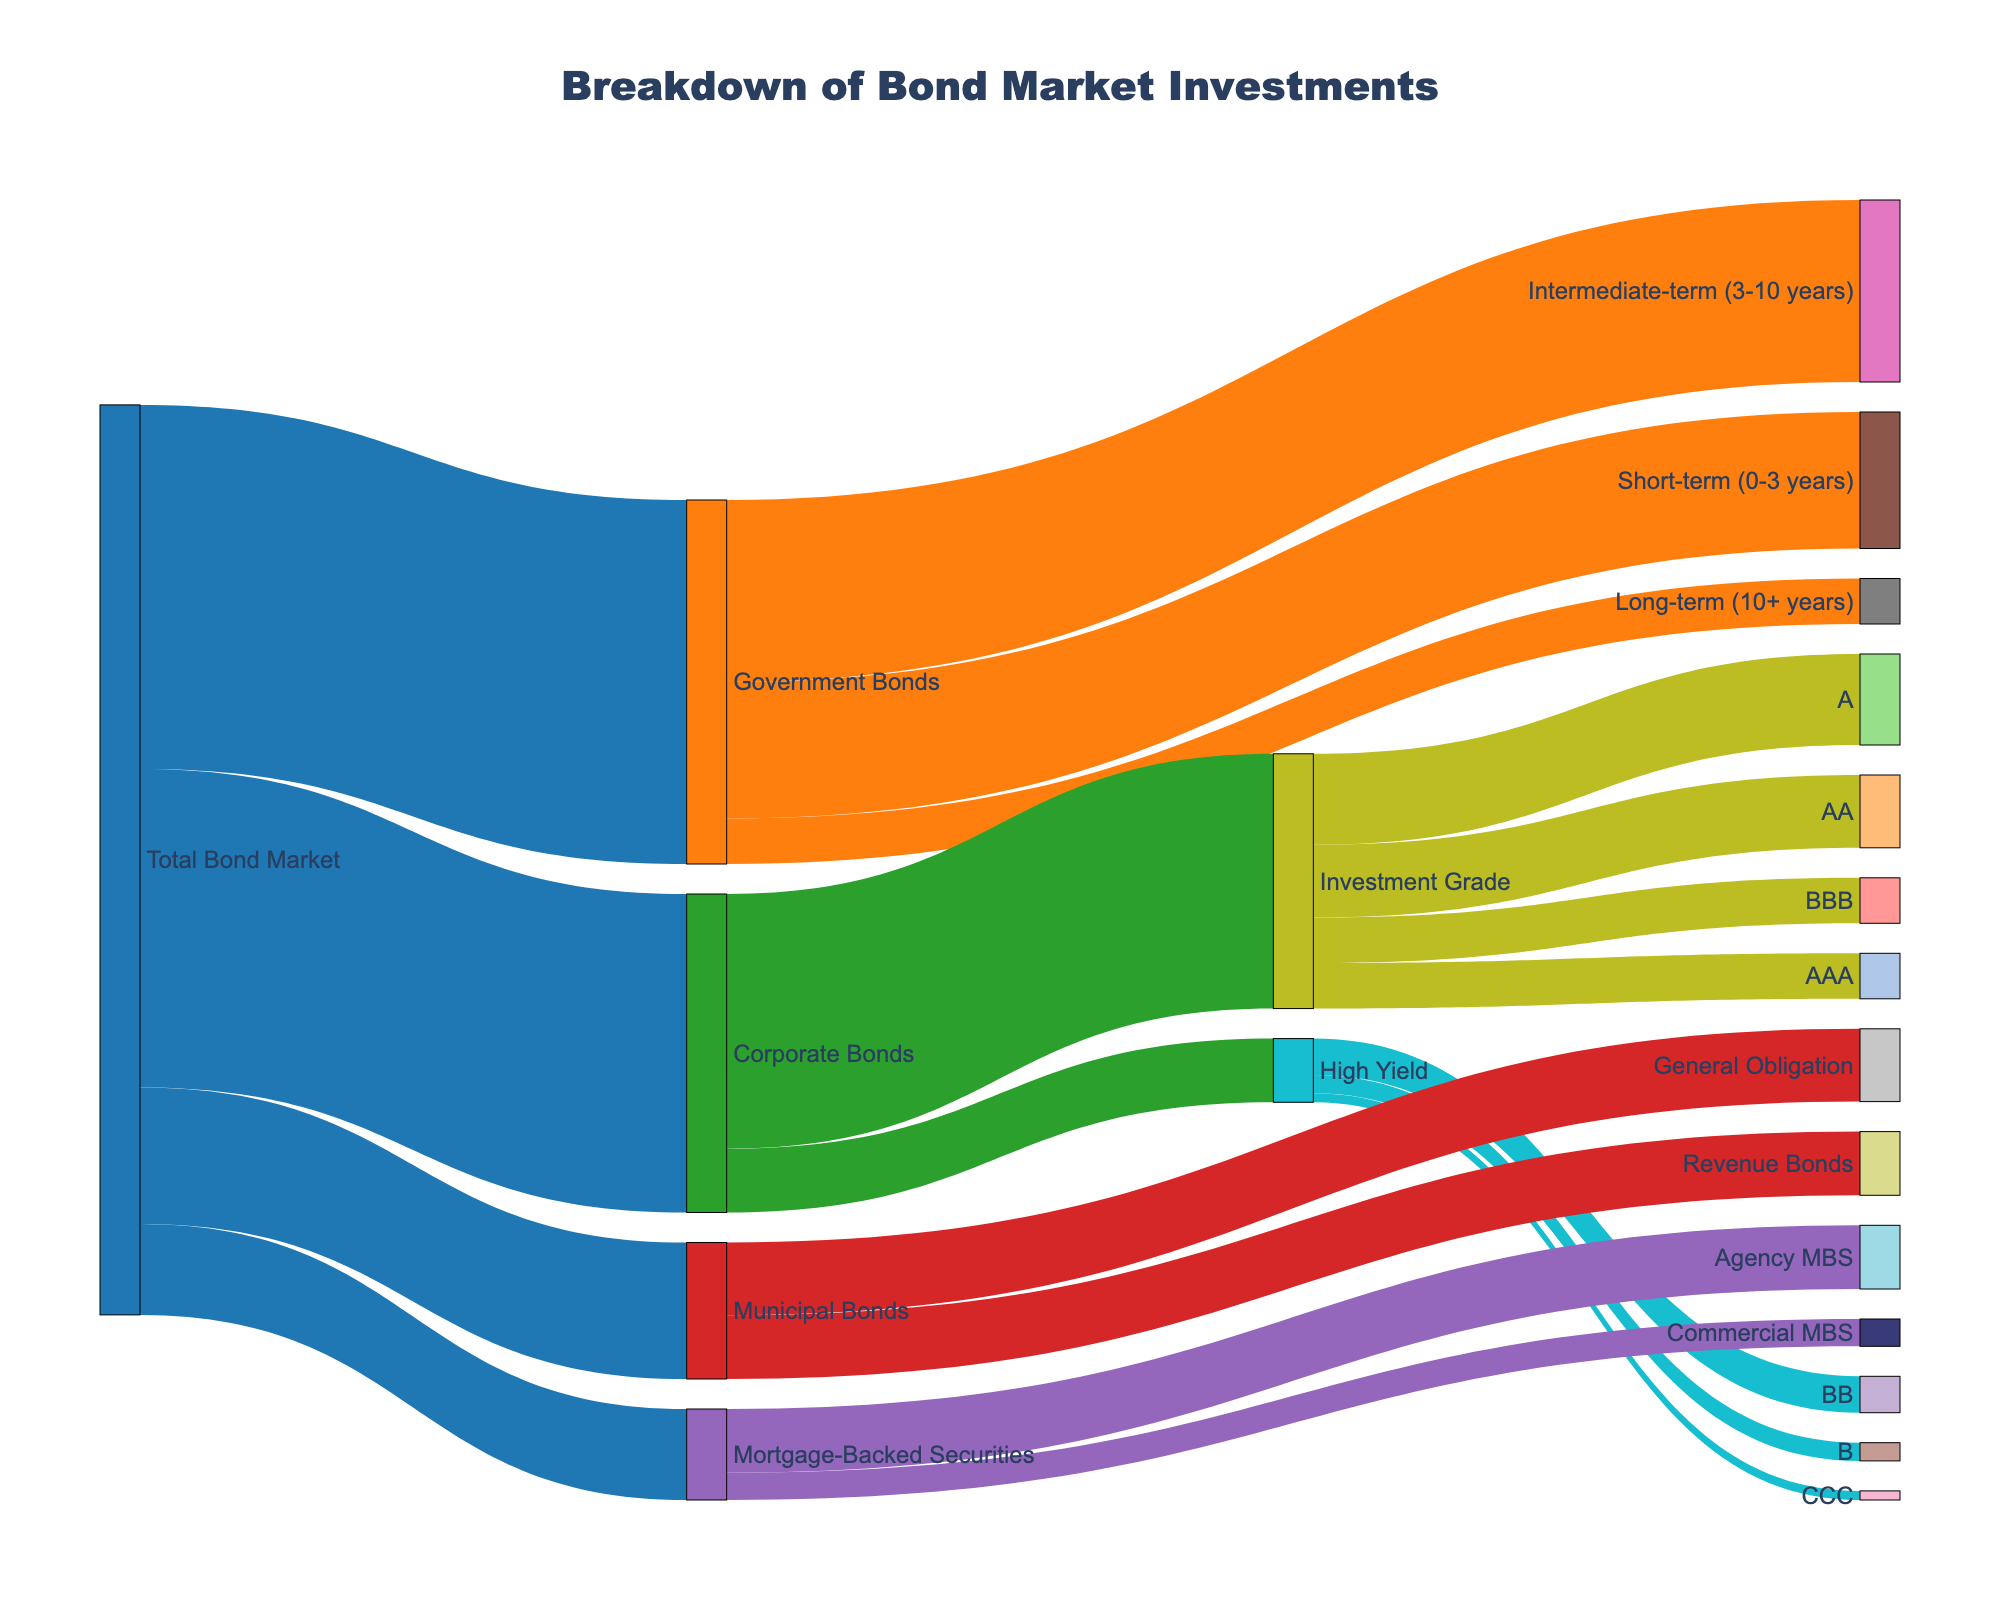What's the title of the figure? The title is typically found at the top of the figure and provides an overview of what the chart illustrates. In this case, it should be read directly from the top-center of the visual.
Answer: Breakdown of Bond Market Investments Which category has the largest share in the Total Bond Market? The four categories originating from the Total Bond Market are Government Bonds, Corporate Bonds, Municipal Bonds, and Mortgage-Backed Securities. Comparing their values directly tells which is the largest.
Answer: Government Bonds How much of the Total Bond Market is in short-term government bonds? Find the flow from Government Bonds to Short-term (0-3 years). This value can be directly read from the diagram.
Answer: 15 What is the total value of Investment Grade holdings in Corporate Bonds? Sum the values flowing from Corporate Bonds to Investment Grade subcategories (AAA, AA, A, BBB). These values are 5, 8, 10, and 5 respectively.
Answer: 28 Which has a higher value, Municipal Bonds' General Obligation or Revenue Bonds? Compare the values of General Obligation and Revenue Bonds shown in the flows originating from Municipal Bonds. General Obligation is 8 and Revenue Bonds is 7.
Answer: General Obligation How does the value of Mortgage-Backed Securities compare to Municipal Bonds? Compare the total values indicated for Mortgage-Backed Securities (10) and Municipal Bonds (15). Municipal Bonds are clearly higher.
Answer: Municipal Bonds What is the value distribution within High Yield Corporate Bonds? Identify and add the values for the target categories connected to High Yield (BB, B, CCC): 4, 2, and 1 respectively. Confirm the sum equals 7.
Answer: 4 (BB), 2 (B), 1 (CCC) What is the second largest government bond category in terms of duration? Examine the Government Bonds' connections to different durations and identify the second largest value after Intermediate-term (20), which is Short-term (15).
Answer: Short-term What is the total value of Corporate Bonds including both Investment Grade and High Yield? Sum the values for Investment Grade and High Yield Corporate Bonds: 28 (Investment Grade) + 7 (High Yield).
Answer: 35 In which category is the value of AA-rated investment grade bonds found? Look at the flow from Investment Grade to AA directly to determine the value.
Answer: 8 